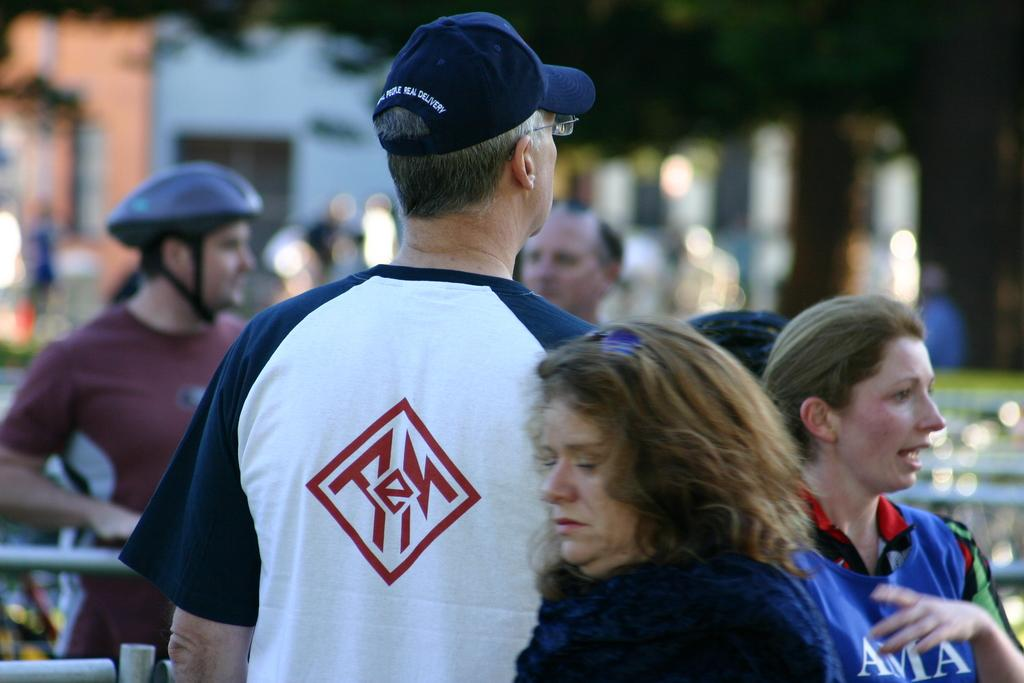<image>
Present a compact description of the photo's key features. A number of people standing around at an AMA event. 